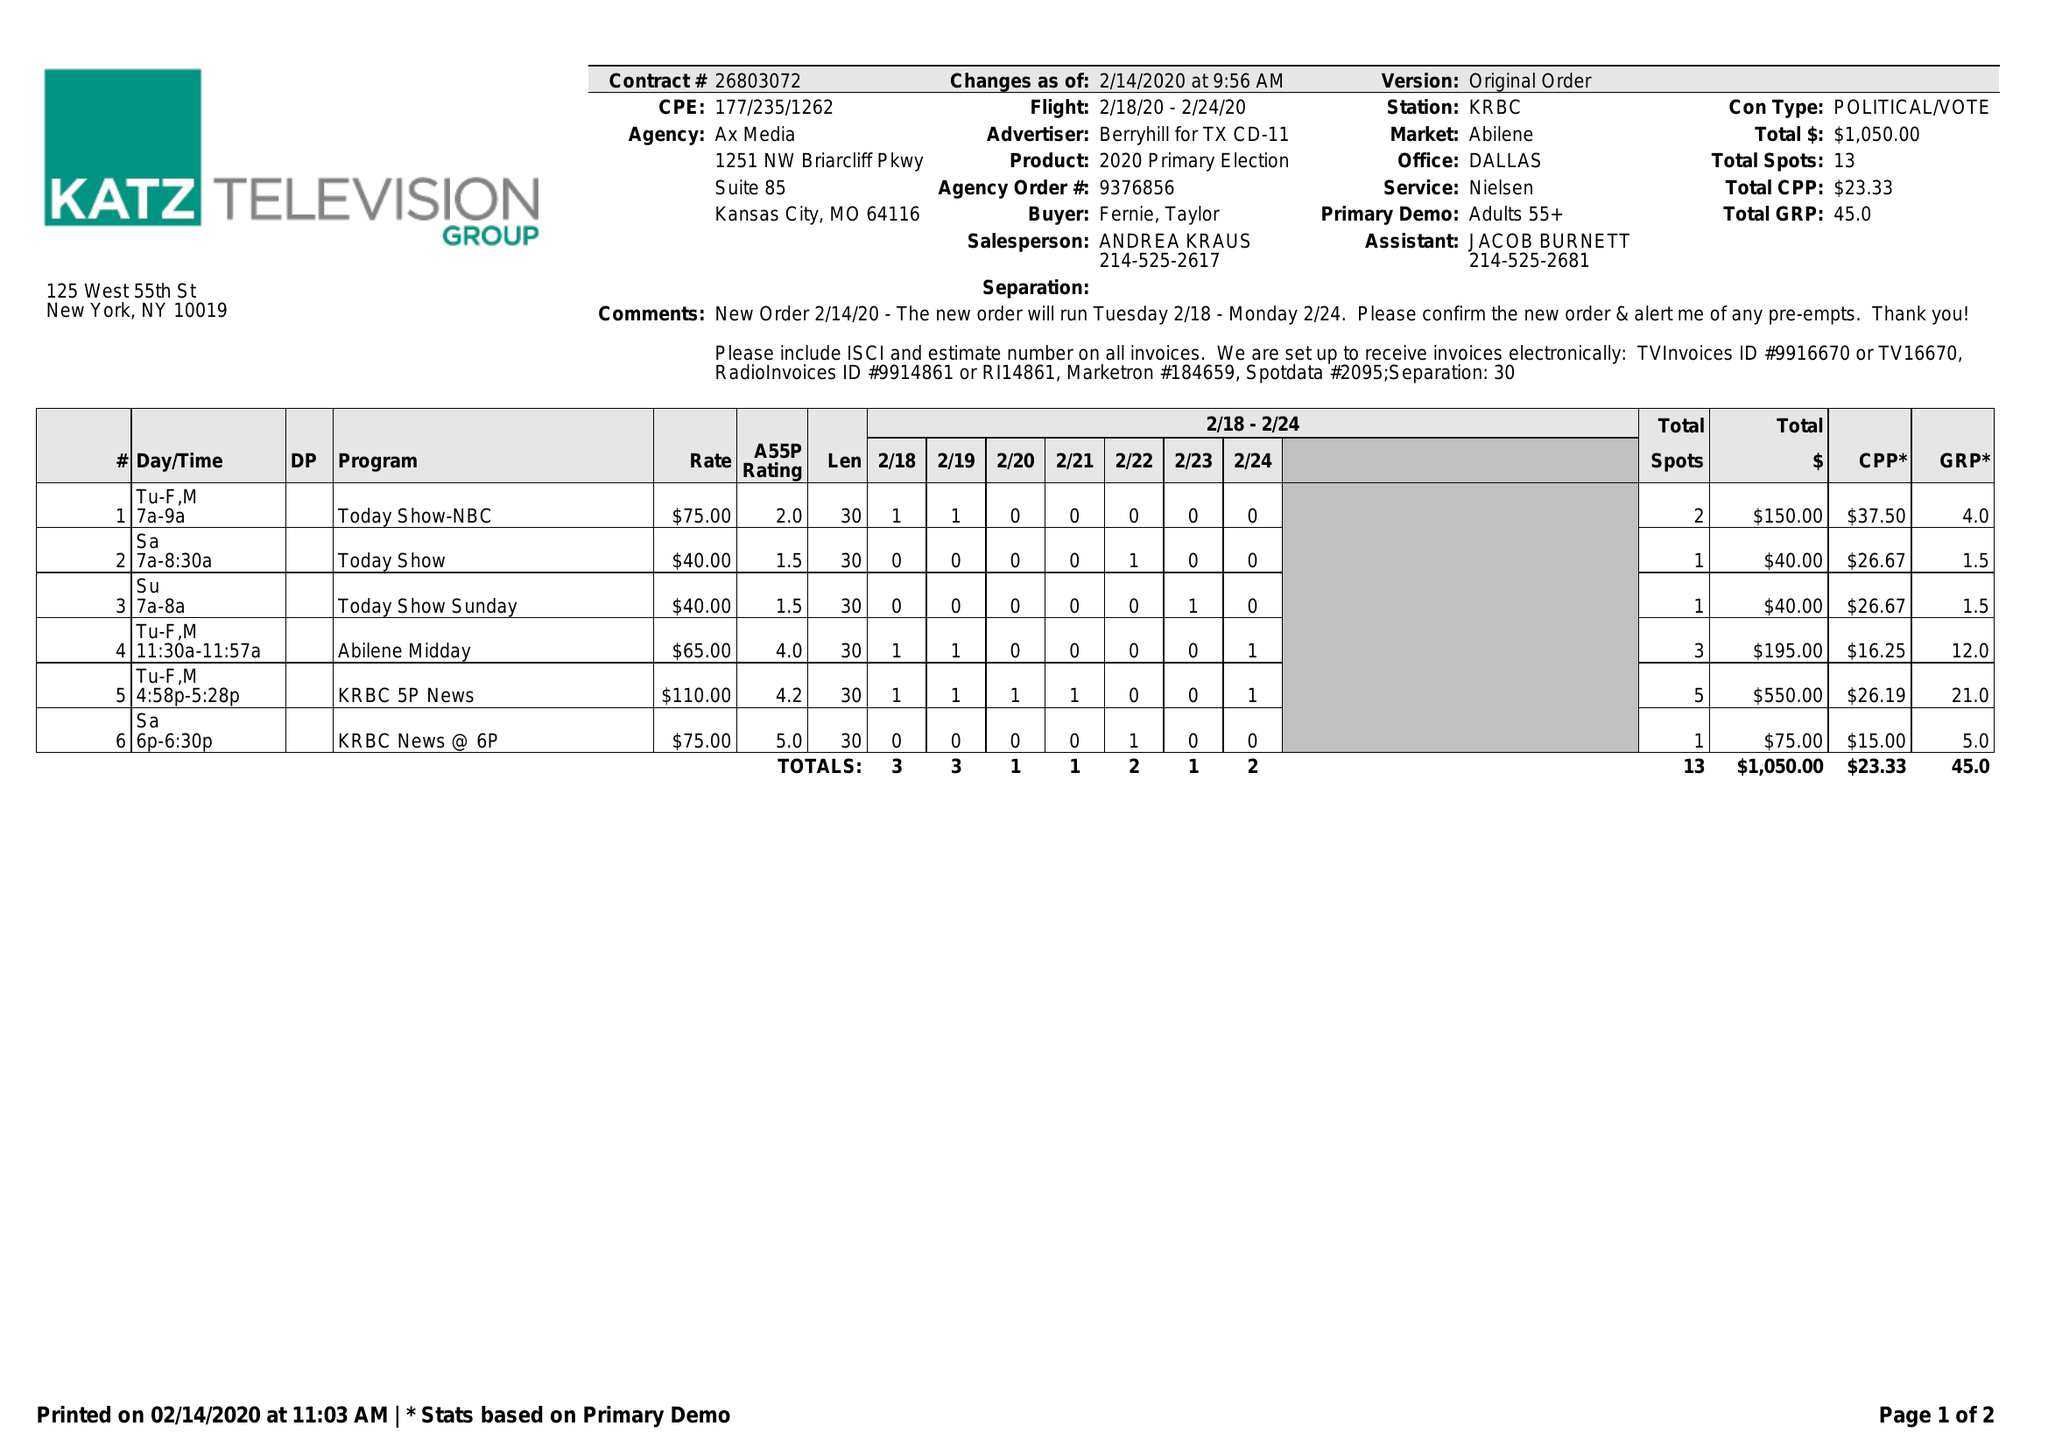What is the value for the advertiser?
Answer the question using a single word or phrase. BERRYHILL FOR TX CD-11 